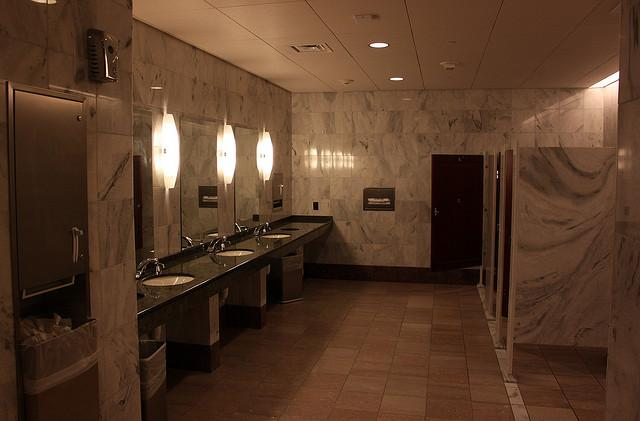Where might this bathroom be? casino 